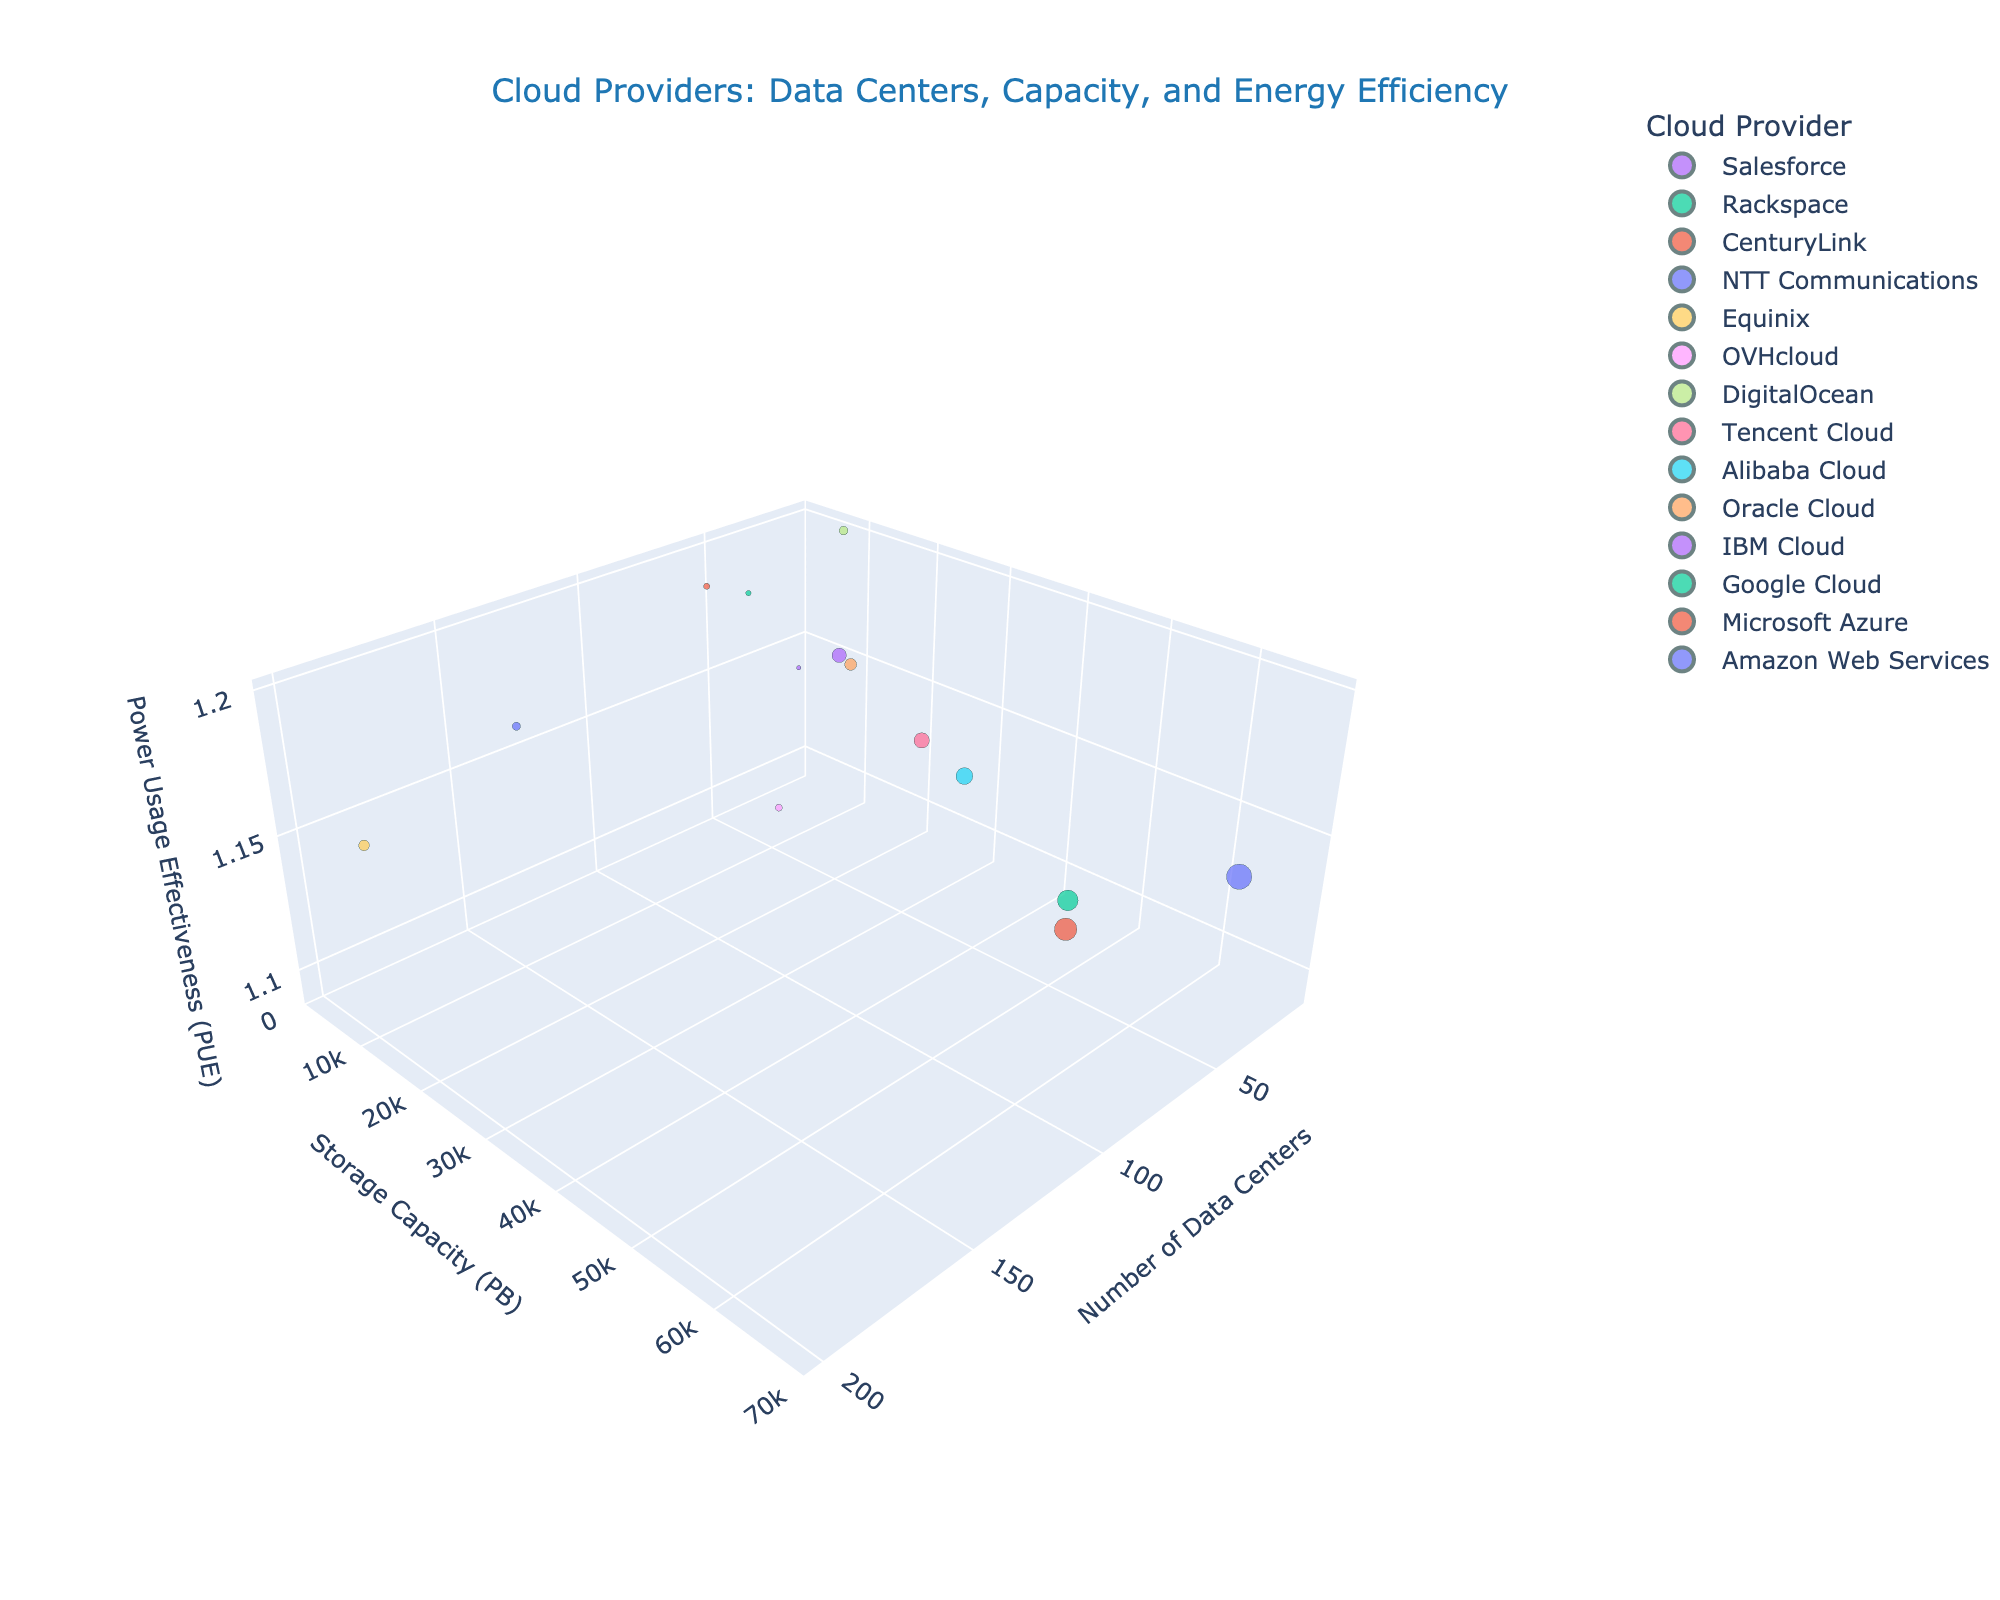How many cloud providers are represented in the plot? Look at the legend which lists the different cloud providers. The number of unique providers given in the plot corresponds to the number of data points with different colors.
Answer: 14 Which cloud provider has the highest number of data centers? By visually inspecting the x-axis ('Number of Data Centers'), locate the data point that is furthest to the right.
Answer: Equinix What is the most energy-efficient cloud provider based on PUE? Look for the data point that is positioned lowest along the z-axis, which represents the 'Power Usage Effectiveness (PUE)'.
Answer: OVHcloud Which cloud provider has the highest storage capacity? Check the y-axis ('Storage Capacity (PB)') and identify the data point that is highest on this axis.
Answer: Amazon Web Services Which cloud provider has the fewest locations and the smallest capacity? Look for the smallest markers near the origin (closest to where x and y-axes meet), then compare their capacity (size).
Answer: DigitalOcean What is the PUE of the cloud provider with the highest number of data centers? Locate the data point for Equinix, which has the highest number of data centers, then check its position along the z-axis for the PUE value.
Answer: 1.16 Compare the storage capacity between IBM Cloud and Google Cloud. Which one is larger? Locate the data points for IBM Cloud and Google Cloud, then compare their positions along the y-axis ('Storage Capacity (PB)').
Answer: Google Cloud By how many data centers does Microsoft Azure exceed IBM Cloud? Find the data points for both Microsoft Azure and IBM Cloud, then calculate the difference in the 'Number of Data Centers' (x-axis). Microsoft Azure has 60, and IBM Cloud has 55. The difference is 60 - 55.
Answer: 5 What is the average PUE of all represented cloud providers? Sum the PUE values of all data points and divide by the number of providers. The sum of PUE values is (1.15 + 1.12 + 1.10 + 1.18 + 1.16 + 1.13 + 1.14 + 1.20 + 1.09 + 1.16 + 1.17 + 1.19 + 1.18 + 1.14) = 15.11. Divide 15.11 by 14 providers.
Answer: 1.08 Which provider has a higher PUE, Alibaba Cloud or CenturyLink? Locate the data points for Alibaba Cloud and CenturyLink and compare their positions along the z-axis ('PUE').
Answer: CenturyLink 